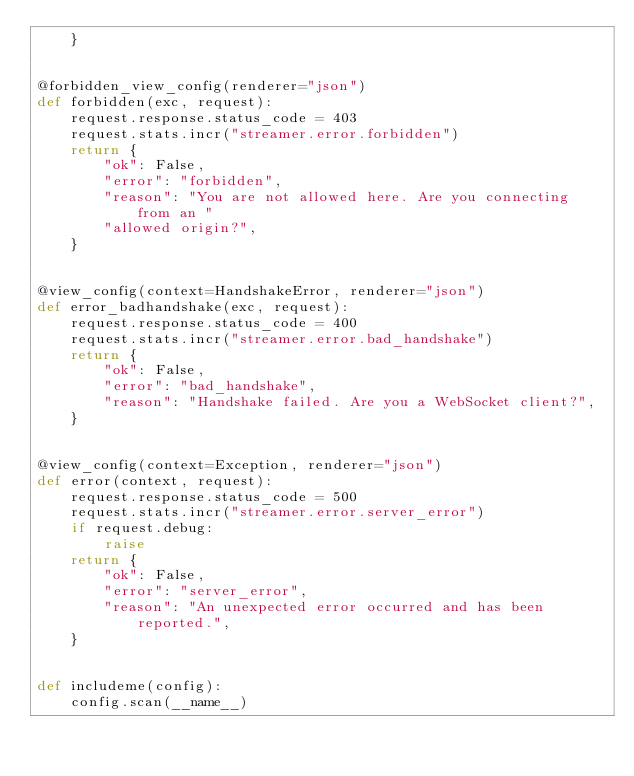<code> <loc_0><loc_0><loc_500><loc_500><_Python_>    }


@forbidden_view_config(renderer="json")
def forbidden(exc, request):
    request.response.status_code = 403
    request.stats.incr("streamer.error.forbidden")
    return {
        "ok": False,
        "error": "forbidden",
        "reason": "You are not allowed here. Are you connecting from an "
        "allowed origin?",
    }


@view_config(context=HandshakeError, renderer="json")
def error_badhandshake(exc, request):
    request.response.status_code = 400
    request.stats.incr("streamer.error.bad_handshake")
    return {
        "ok": False,
        "error": "bad_handshake",
        "reason": "Handshake failed. Are you a WebSocket client?",
    }


@view_config(context=Exception, renderer="json")
def error(context, request):
    request.response.status_code = 500
    request.stats.incr("streamer.error.server_error")
    if request.debug:
        raise
    return {
        "ok": False,
        "error": "server_error",
        "reason": "An unexpected error occurred and has been reported.",
    }


def includeme(config):
    config.scan(__name__)
</code> 